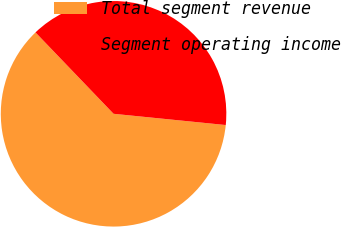Convert chart to OTSL. <chart><loc_0><loc_0><loc_500><loc_500><pie_chart><fcel>Total segment revenue<fcel>Segment operating income<nl><fcel>61.24%<fcel>38.76%<nl></chart> 